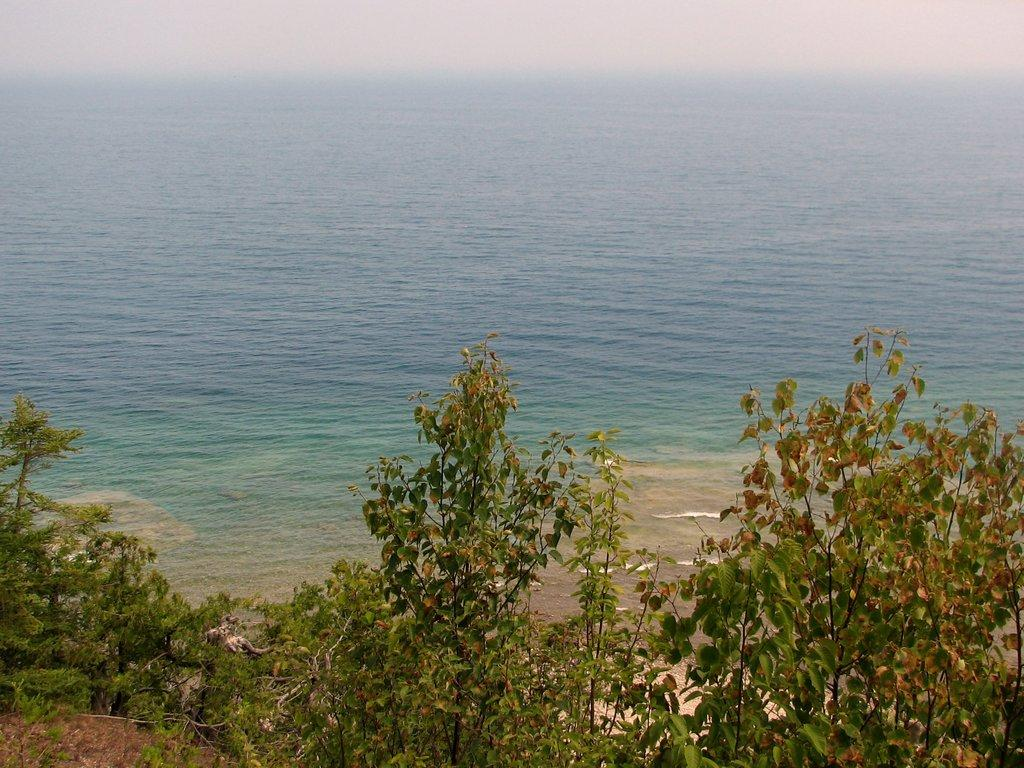What type of vegetation is on the hill in the image? There are trees on a hill in the image. What is the hill situated near? The hill is near a sand surface. What natural feature is the sand surface near? The sand surface is near the tides of the ocean. What can be seen in the sky in the background of the image? There are clouds in the sky in the background. What date is marked on the calendar hanging from the tree on the hill? There is no calendar present in the image; it only features trees on a hill, a sand surface, and clouds in the sky. What type of leaf can be seen falling from the tree on the hill? There are no leaves falling from the trees in the image, as the trees are on a hill near a sand surface and the tides of the ocean. 